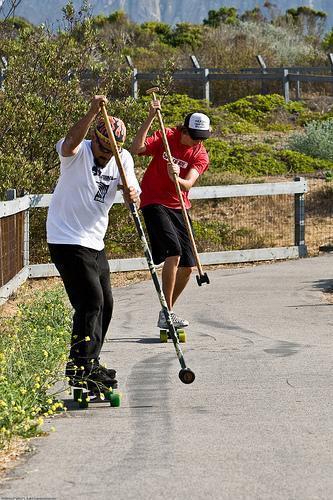How many people are racing?
Give a very brief answer. 2. 